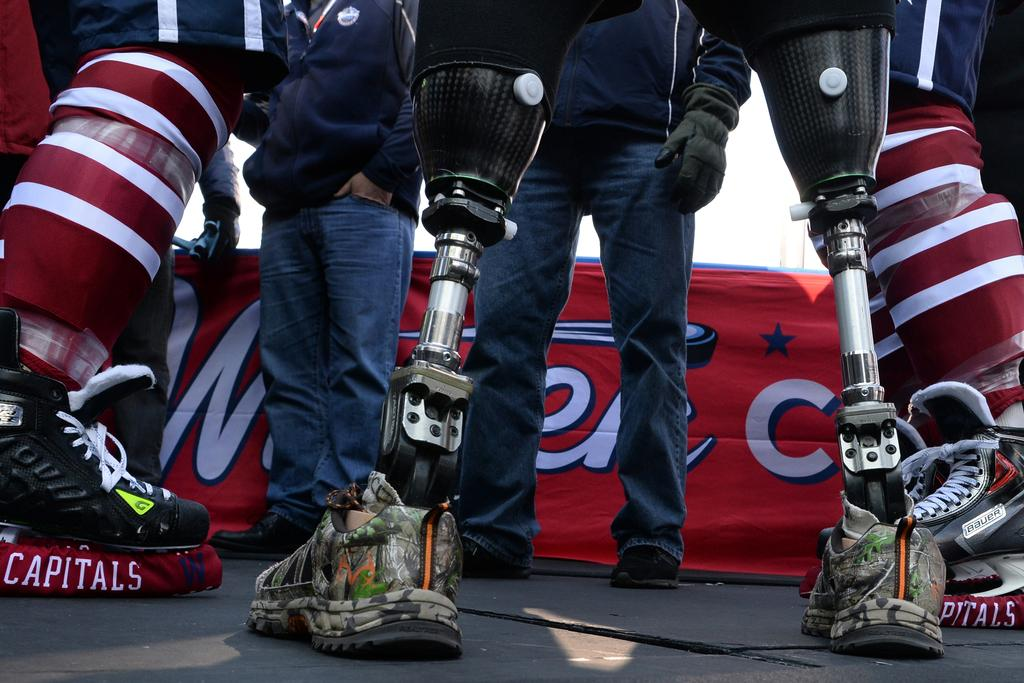What is unique about the person in the image? The person in the image has artificial limbs. How many other people are in the image? There are two other persons standing in front of the person with artificial limbs. What type of mask is the person wearing in the image? There is no mask present in the image; the person has artificial limbs. 